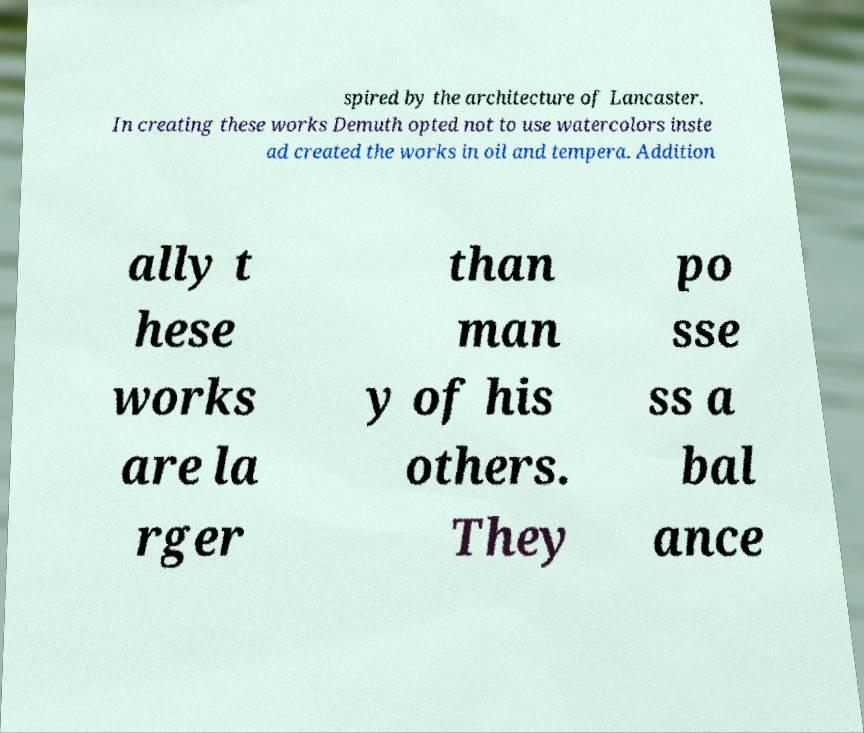Please identify and transcribe the text found in this image. spired by the architecture of Lancaster. In creating these works Demuth opted not to use watercolors inste ad created the works in oil and tempera. Addition ally t hese works are la rger than man y of his others. They po sse ss a bal ance 